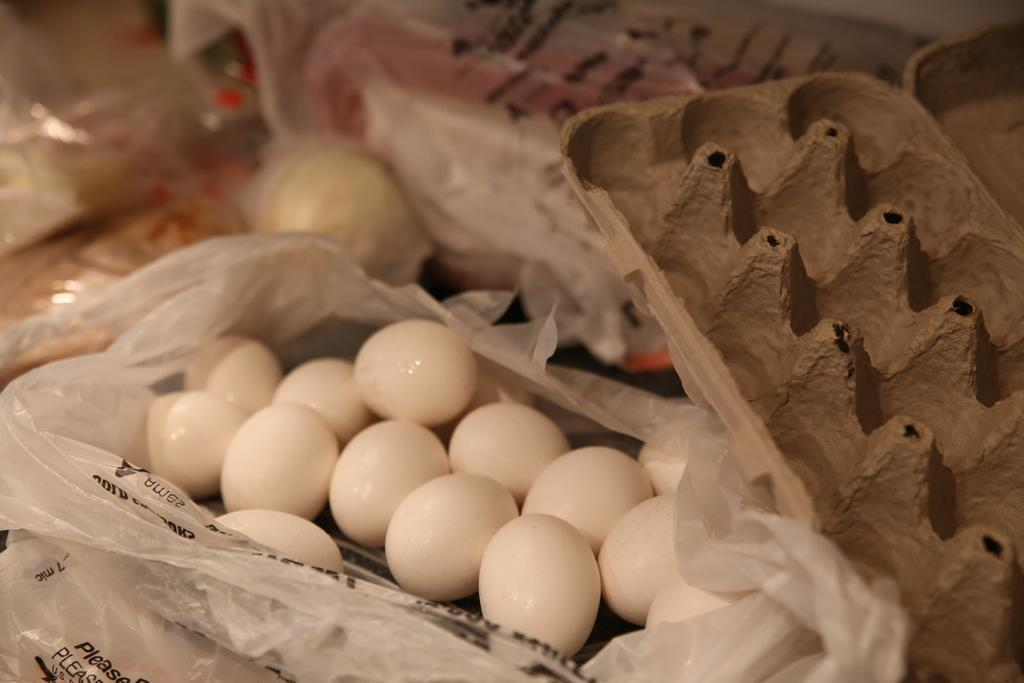What can be seen in the image related to eggs? There are some eggs and egg trays in the image. What type of covers are present in the image? There are plastic covers in the image. What can be observed in the background of the image? There are objects in the background of the image. Are there any plastic covers visible in the background? Yes, there are plastic covers in the background of the image. How does the image show the process of transporting eggs? The image does not show the process of transporting eggs; it only displays eggs, egg trays, and plastic covers. 